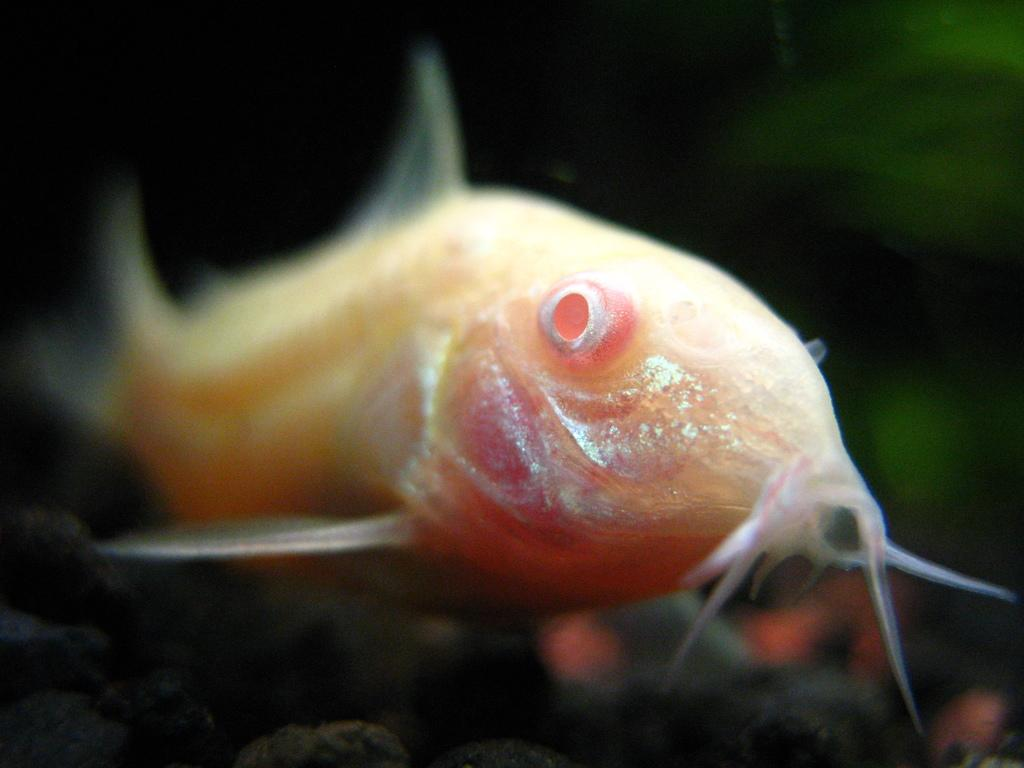What type of animal is in the image? There is a fish in the image. Can you describe the color of the fish? The fish is white, cream, and pink in color. What can be seen in the background of the image? The background of the image is dark. What type of toothpaste is the fish using in the image? There is no toothpaste present in the image, and fish do not use toothpaste. 